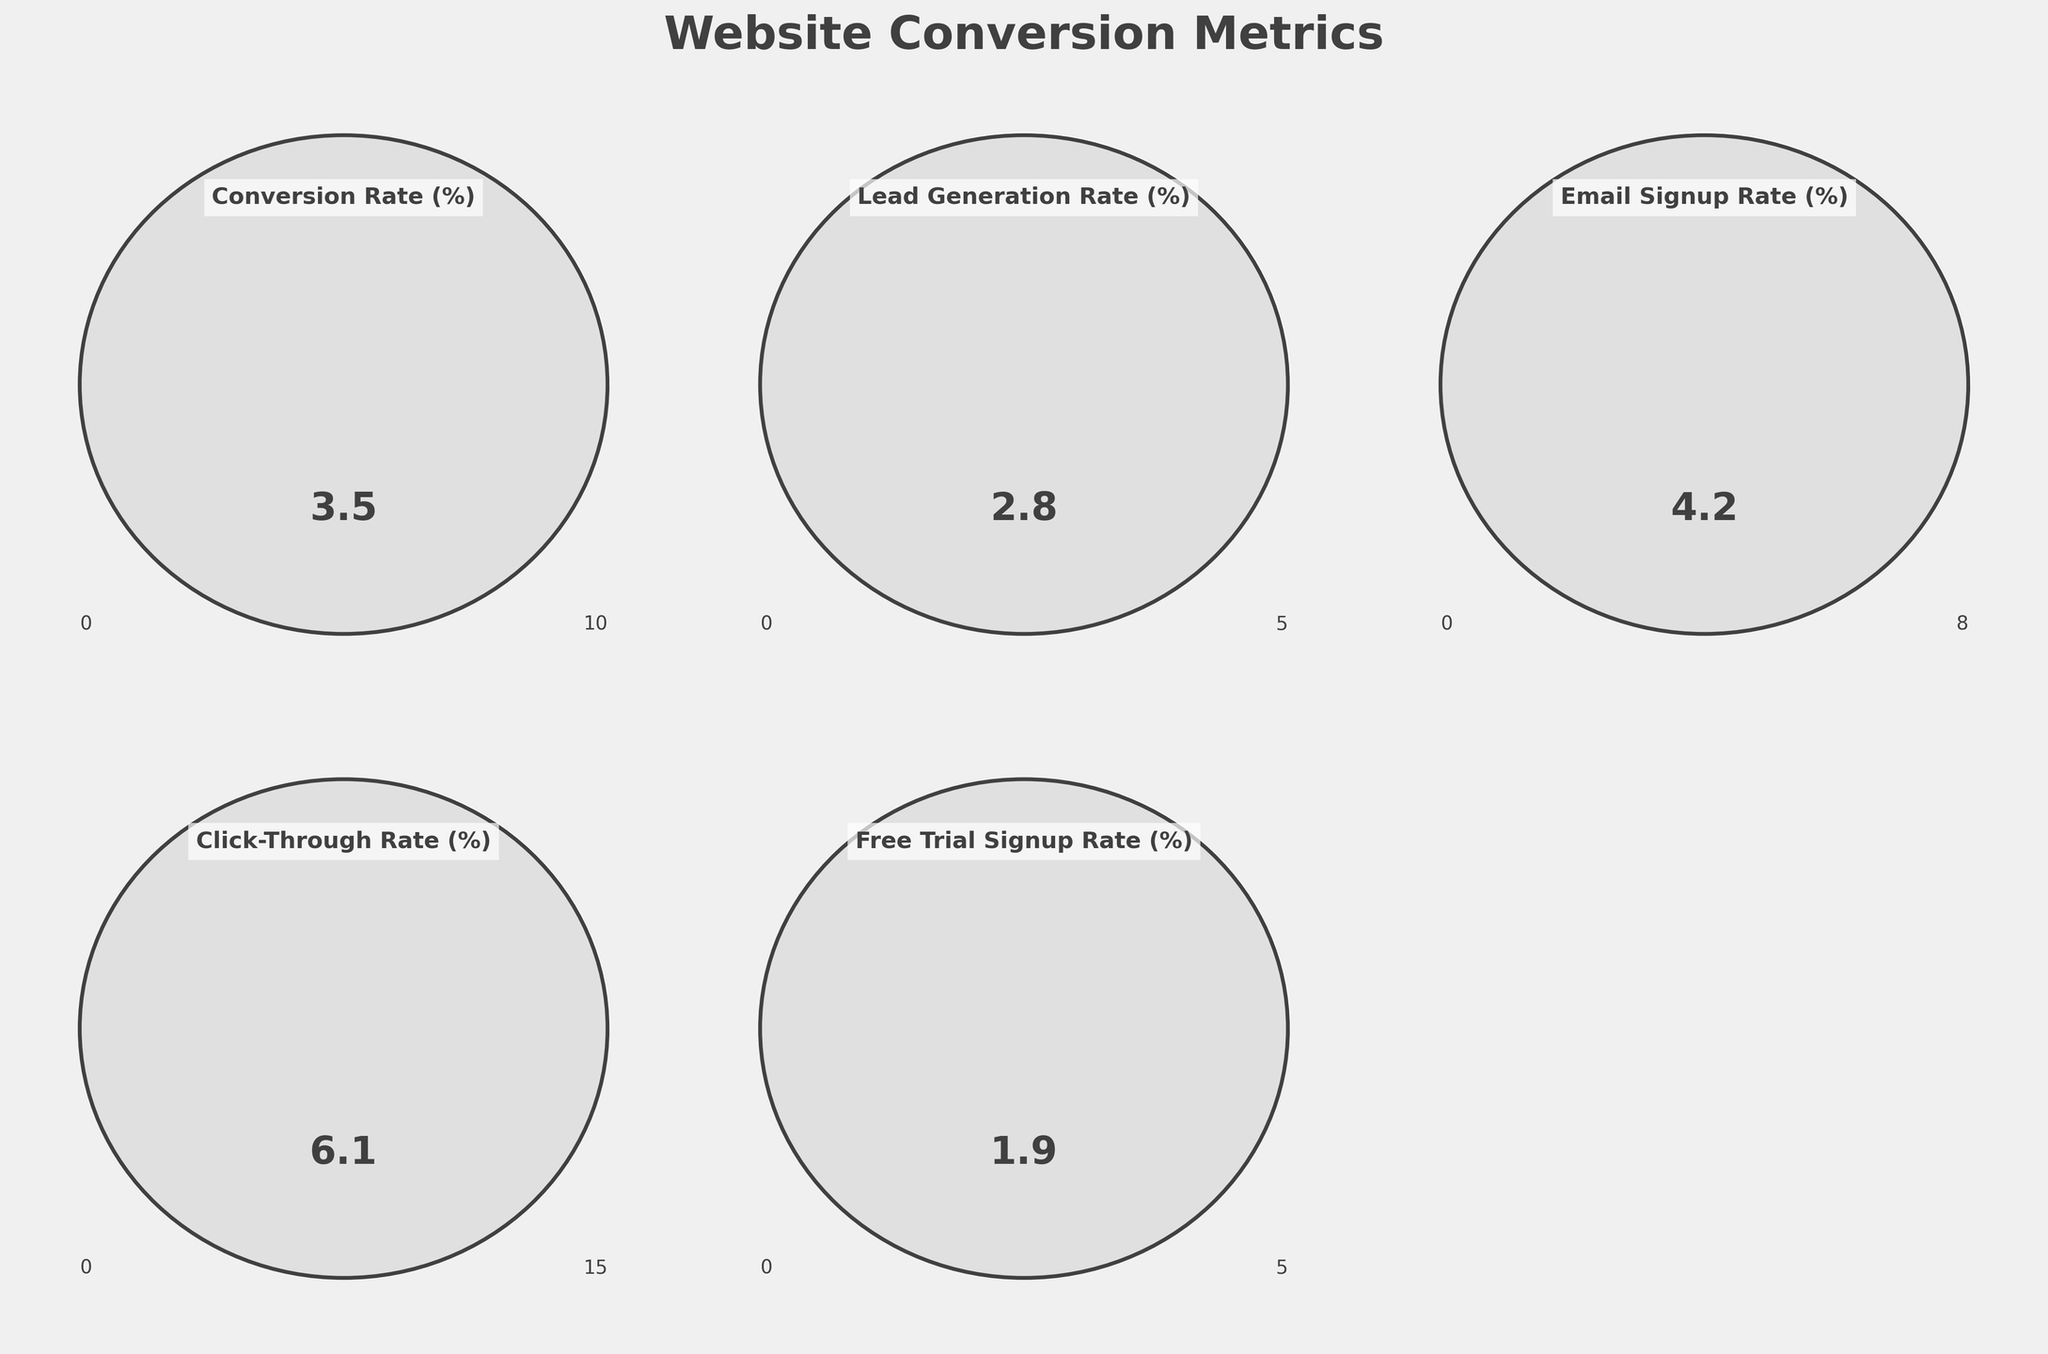What is the conversion rate percentage displayed in the gauge chart? The conversion rate percentage is displayed as a numerical value inside the gauge. We can see that it is 3.5% based on the number indicated inside the gauge for "Conversion Rate (%)".
Answer: 3.5% What is the highest metric value among all the website conversion metrics? To identify the highest metric value, we look at all the numerical values displayed inside the gauge charts. The highest value is 6.1% in the "Click-Through Rate (%)" gauge.
Answer: 6.1% Which metric has the lowest possible maximum value in its gauge chart? To find the metric with the lowest possible maximum value, we identify the minimum values displayed on each of the gauge's scales. "Lead Generation Rate (%)" and "Free Trial Signup Rate (%)" have a maximum value of 5. Therefore, both are the lowest.
Answer: Lead Generation Rate (%), Free Trial Signup Rate (%) What is the range of the "Email Signup Rate (%)" gauge chart? The range of a gauge chart is the difference between the maximum and minimum values shown on the gauge. For "Email Signup Rate (%)", the range is from 0 to 8. The difference is calculated as 8 - 0.
Answer: 8 How much higher is the "Click-Through Rate (%)" compared to the "Lead Generation Rate (%)"? To determine the difference, subtract the "Lead Generation Rate (%)" value from the "Click-Through Rate (%)" value. The "Click-Through Rate (%)" is 6.1 and the "Lead Generation Rate (%)" is 2.8. So, 6.1 - 2.8 equals 3.3.
Answer: 3.3 Which two metrics have the same minimum value? By observing the minimum values displayed at the bottom left of each gauge chart, we can see that all gauges have a minimum value of 0. Hence, all metrics in the chart have the same minimum value.
Answer: All metrics What is the average value of all the website conversion metrics on the chart? To calculate the average, add up all the displayed values and divide by the number of metrics. The values are 3.5, 2.8, 4.2, 6.1, and 1.9. The sum is 3.5 + 2.8 + 4.2 + 6.1 + 1.9 = 18.5. Dividing by 5 (the number of metrics) gives us 18.5 / 5 = 3.7.
Answer: 3.7 Which metric shows a performance level colored in light blue? The light blue-colored gauge can be identified visually. In the given data, "Email Signup Rate (%)" is represented in light blue.
Answer: Email Signup Rate (%) 